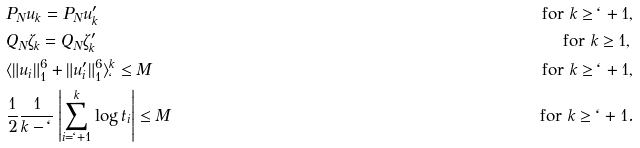<formula> <loc_0><loc_0><loc_500><loc_500>& P _ { N } u _ { k } = P _ { N } u _ { k } ^ { \prime } & \text {for $k\geq\ell+1,$} \\ & Q _ { N } \zeta _ { k } = Q _ { N } \zeta _ { k } ^ { \prime } & \text {for $k\geq1,\, $} \\ & \langle \| u _ { i } \| _ { 1 } ^ { 6 } + \| u _ { i } ^ { \prime } \| _ { 1 } ^ { 6 } \rangle _ { \ell } ^ { k } \leq M & \text {for $k\geq\ell+1,$} \\ & \frac { 1 } { 2 } \frac { 1 } { k - \ell } \left | \sum _ { i = \ell + 1 } ^ { k } \log t _ { i } \right | \leq M & \text {for $k\geq\ell+1$} .</formula> 